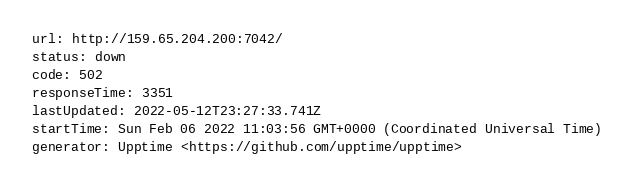Convert code to text. <code><loc_0><loc_0><loc_500><loc_500><_YAML_>url: http://159.65.204.200:7042/
status: down
code: 502
responseTime: 3351
lastUpdated: 2022-05-12T23:27:33.741Z
startTime: Sun Feb 06 2022 11:03:56 GMT+0000 (Coordinated Universal Time)
generator: Upptime <https://github.com/upptime/upptime>
</code> 